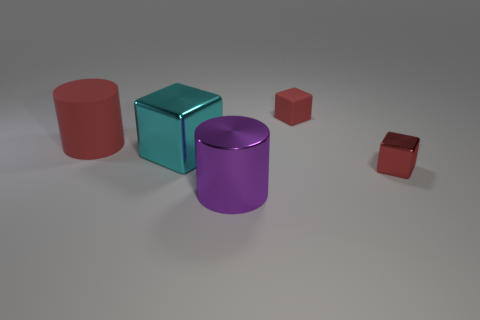Add 1 large purple shiny cylinders. How many objects exist? 6 Subtract all cubes. How many objects are left? 2 Add 5 cyan cubes. How many cyan cubes exist? 6 Subtract 0 blue spheres. How many objects are left? 5 Subtract all large shiny cylinders. Subtract all small metallic objects. How many objects are left? 3 Add 3 large red rubber things. How many large red rubber things are left? 4 